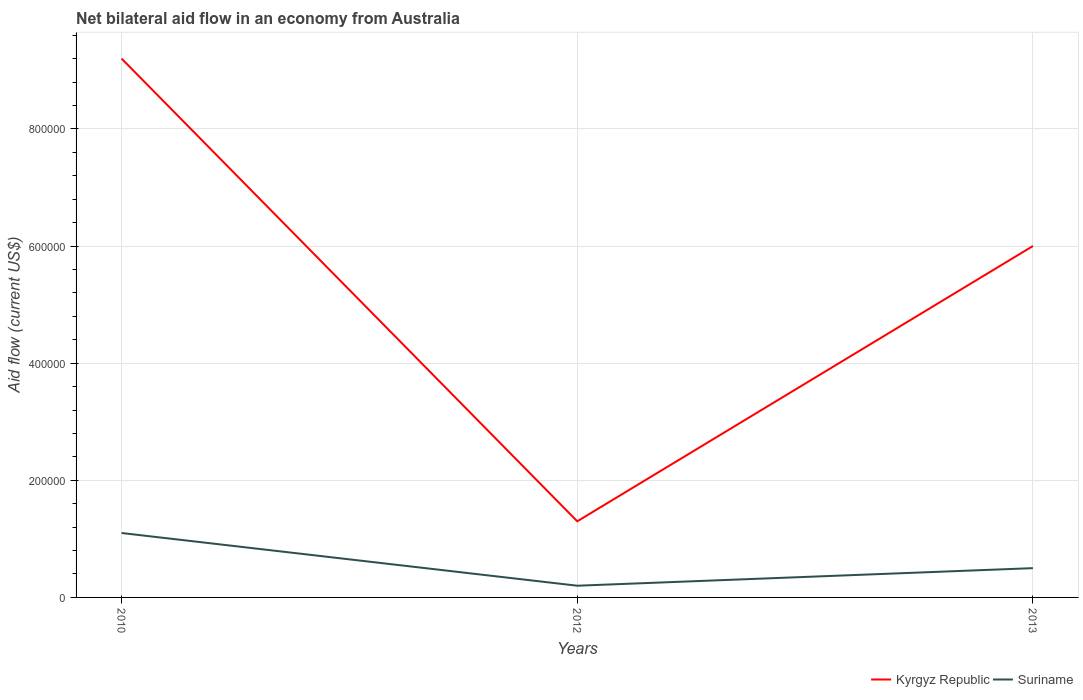Does the line corresponding to Suriname intersect with the line corresponding to Kyrgyz Republic?
Your answer should be compact. No. What is the total net bilateral aid flow in Kyrgyz Republic in the graph?
Offer a very short reply. 3.20e+05. What is the difference between the highest and the second highest net bilateral aid flow in Kyrgyz Republic?
Ensure brevity in your answer.  7.90e+05. What is the difference between the highest and the lowest net bilateral aid flow in Suriname?
Give a very brief answer. 1. Is the net bilateral aid flow in Suriname strictly greater than the net bilateral aid flow in Kyrgyz Republic over the years?
Offer a very short reply. Yes. How many lines are there?
Make the answer very short. 2. Are the values on the major ticks of Y-axis written in scientific E-notation?
Provide a succinct answer. No. Does the graph contain any zero values?
Provide a succinct answer. No. Does the graph contain grids?
Provide a succinct answer. Yes. How many legend labels are there?
Give a very brief answer. 2. What is the title of the graph?
Offer a very short reply. Net bilateral aid flow in an economy from Australia. What is the label or title of the X-axis?
Provide a succinct answer. Years. What is the Aid flow (current US$) of Kyrgyz Republic in 2010?
Provide a succinct answer. 9.20e+05. What is the Aid flow (current US$) in Kyrgyz Republic in 2012?
Your answer should be compact. 1.30e+05. What is the Aid flow (current US$) of Suriname in 2012?
Your answer should be compact. 2.00e+04. What is the Aid flow (current US$) in Suriname in 2013?
Offer a very short reply. 5.00e+04. Across all years, what is the maximum Aid flow (current US$) of Kyrgyz Republic?
Keep it short and to the point. 9.20e+05. Across all years, what is the maximum Aid flow (current US$) in Suriname?
Provide a short and direct response. 1.10e+05. Across all years, what is the minimum Aid flow (current US$) of Suriname?
Give a very brief answer. 2.00e+04. What is the total Aid flow (current US$) in Kyrgyz Republic in the graph?
Your answer should be very brief. 1.65e+06. What is the total Aid flow (current US$) in Suriname in the graph?
Keep it short and to the point. 1.80e+05. What is the difference between the Aid flow (current US$) of Kyrgyz Republic in 2010 and that in 2012?
Your response must be concise. 7.90e+05. What is the difference between the Aid flow (current US$) in Suriname in 2010 and that in 2012?
Make the answer very short. 9.00e+04. What is the difference between the Aid flow (current US$) in Kyrgyz Republic in 2010 and that in 2013?
Your answer should be very brief. 3.20e+05. What is the difference between the Aid flow (current US$) of Kyrgyz Republic in 2012 and that in 2013?
Make the answer very short. -4.70e+05. What is the difference between the Aid flow (current US$) of Kyrgyz Republic in 2010 and the Aid flow (current US$) of Suriname in 2012?
Give a very brief answer. 9.00e+05. What is the difference between the Aid flow (current US$) in Kyrgyz Republic in 2010 and the Aid flow (current US$) in Suriname in 2013?
Offer a very short reply. 8.70e+05. What is the difference between the Aid flow (current US$) of Kyrgyz Republic in 2012 and the Aid flow (current US$) of Suriname in 2013?
Offer a terse response. 8.00e+04. What is the average Aid flow (current US$) in Kyrgyz Republic per year?
Provide a succinct answer. 5.50e+05. What is the average Aid flow (current US$) of Suriname per year?
Provide a succinct answer. 6.00e+04. In the year 2010, what is the difference between the Aid flow (current US$) of Kyrgyz Republic and Aid flow (current US$) of Suriname?
Provide a short and direct response. 8.10e+05. What is the ratio of the Aid flow (current US$) in Kyrgyz Republic in 2010 to that in 2012?
Give a very brief answer. 7.08. What is the ratio of the Aid flow (current US$) in Kyrgyz Republic in 2010 to that in 2013?
Keep it short and to the point. 1.53. What is the ratio of the Aid flow (current US$) of Kyrgyz Republic in 2012 to that in 2013?
Offer a terse response. 0.22. What is the ratio of the Aid flow (current US$) of Suriname in 2012 to that in 2013?
Your answer should be compact. 0.4. What is the difference between the highest and the second highest Aid flow (current US$) of Kyrgyz Republic?
Make the answer very short. 3.20e+05. What is the difference between the highest and the lowest Aid flow (current US$) in Kyrgyz Republic?
Your answer should be very brief. 7.90e+05. What is the difference between the highest and the lowest Aid flow (current US$) in Suriname?
Give a very brief answer. 9.00e+04. 